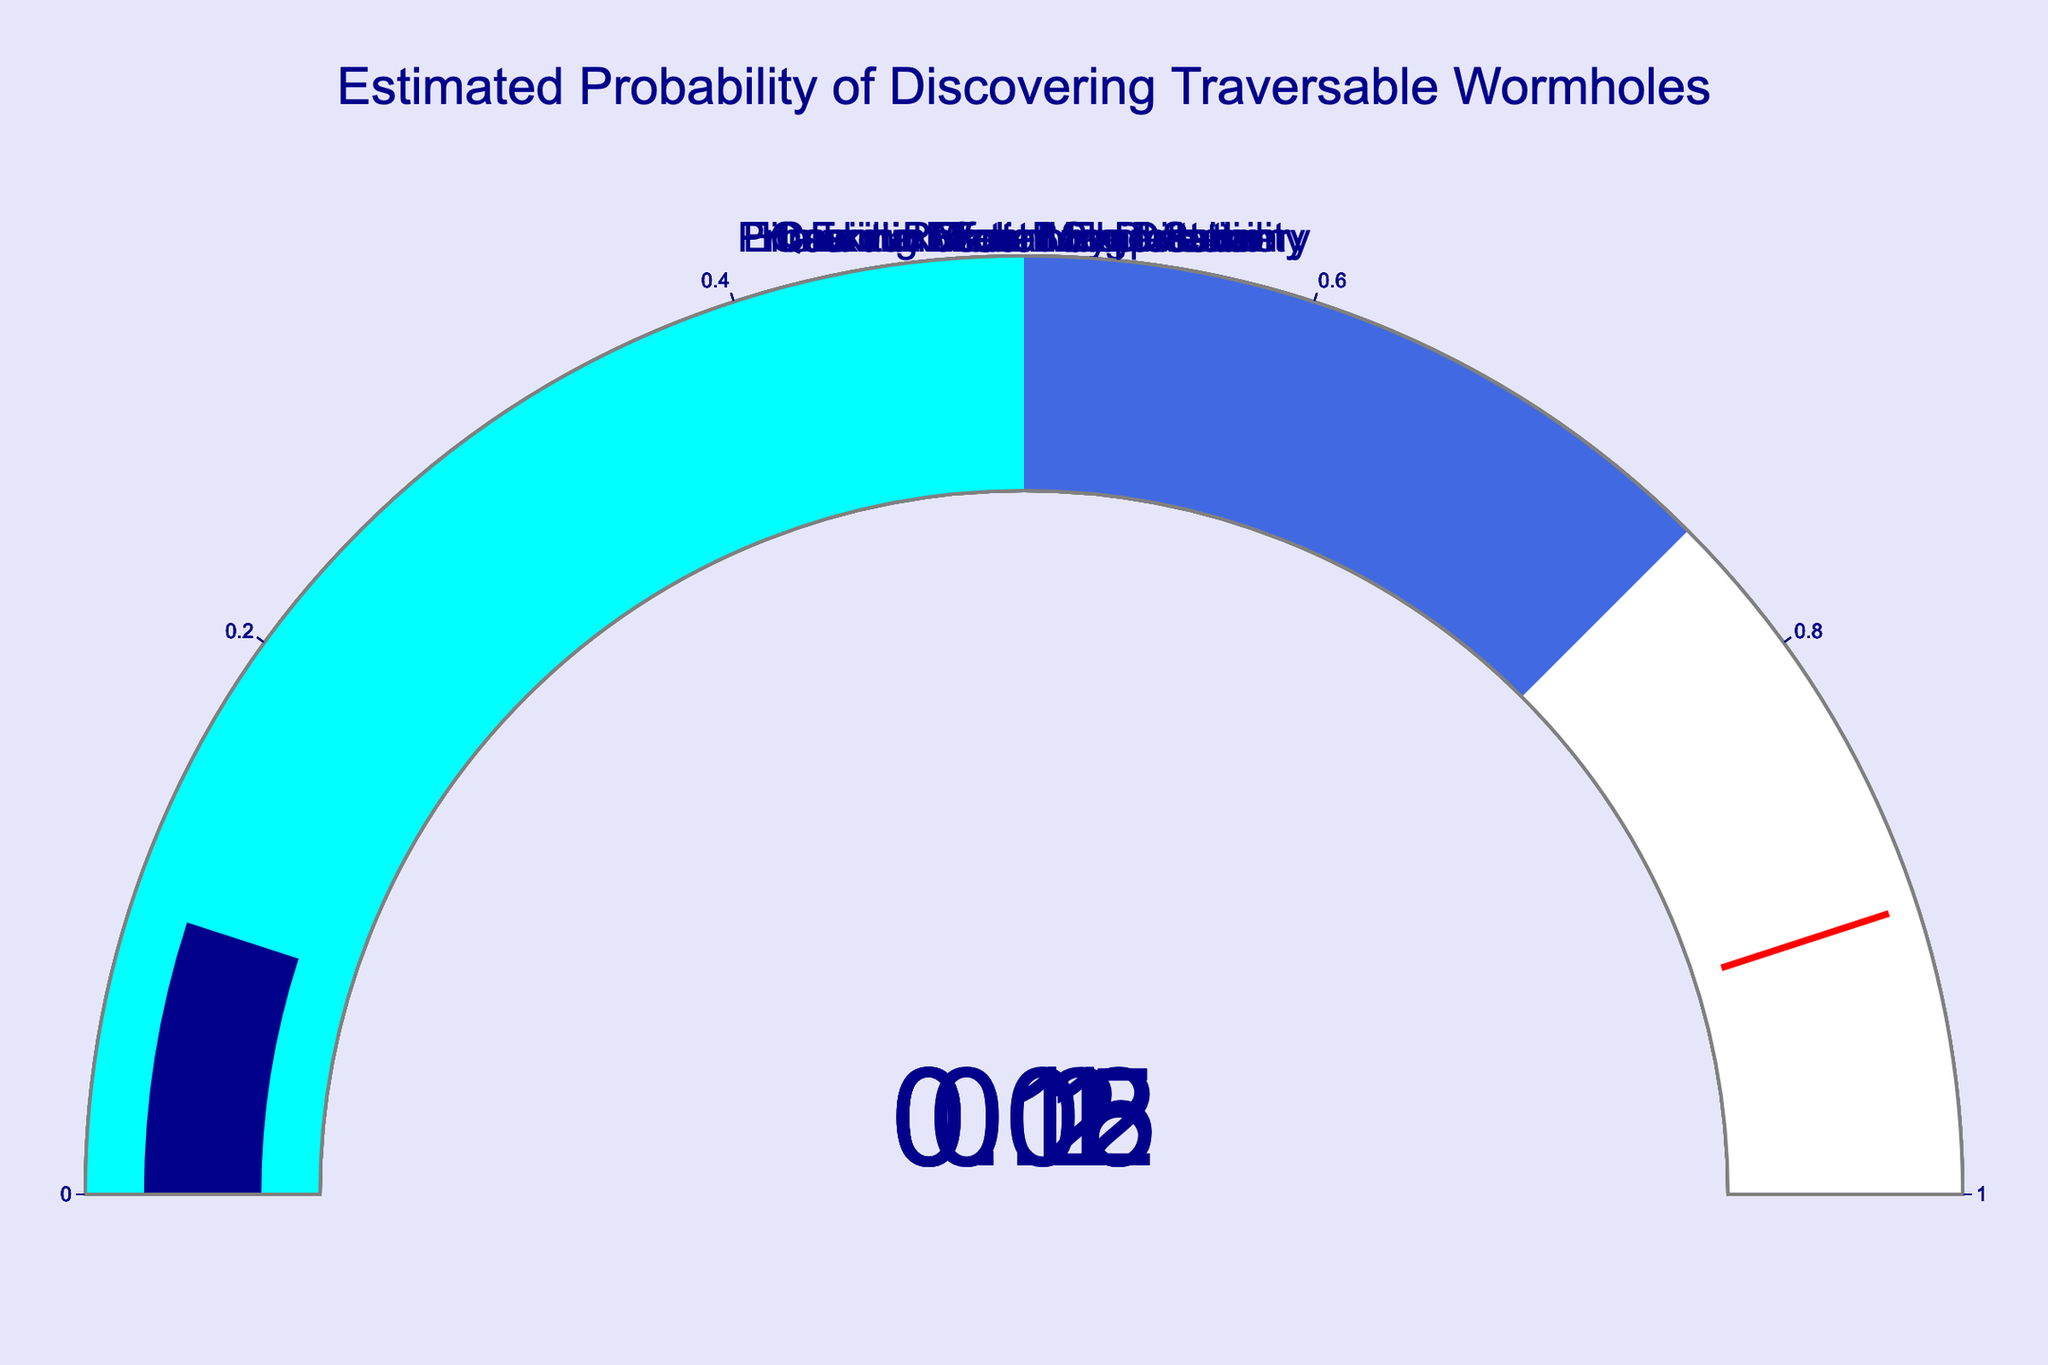What's the estimated probability for Casimir Effect Manipulation? By examining the gauge chart, we observe the probability value displayed for Casimir Effect Manipulation
Answer: 0.20 Which category has the highest estimated probability of discovering traversable wormholes? Compare the displayed numbers across all categories to find the highest value
Answer: Casimir Effect Manipulation What is the sum of the estimated probabilities for Hawking Radiation Detection and Primordial Wormhole Discovery? Add the probability values of Hawking Radiation Detection (0.15) and Primordial Wormhole Discovery (0.08)
Answer: 0.23 How many categories have an estimated probability above 0.1? Identify and count the categories with a probability value greater than 0.1
Answer: 3 Which category has the lowest estimated probability of discovering traversable wormholes? Compare all the probability values and determine the smallest one
Answer: Exotic Matter Synthesis What is the average estimated probability across all categories? Calculate the mean of the probabilities (0.15+0.08+0.12+0.20+0.05+0.10) / 6
Answer: 0.1167 Is the estimated probability of Quantum Foam Exploitation higher than that of Primordial Wormhole Discovery? Compare the probability values of Quantum Foam Exploitation (0.10) and Primordial Wormhole Discovery (0.08)
Answer: Yes Which two categories have a combined probability closest to 0.25? Calculate the sums of pairs of probabilities and find the pair closest to 0.25. For example, (0.15+0.08=0.23), (0.08+0.12=0.20), etc.
Answer: Hawking Radiation Detection & Primordial Wormhole Discovery 